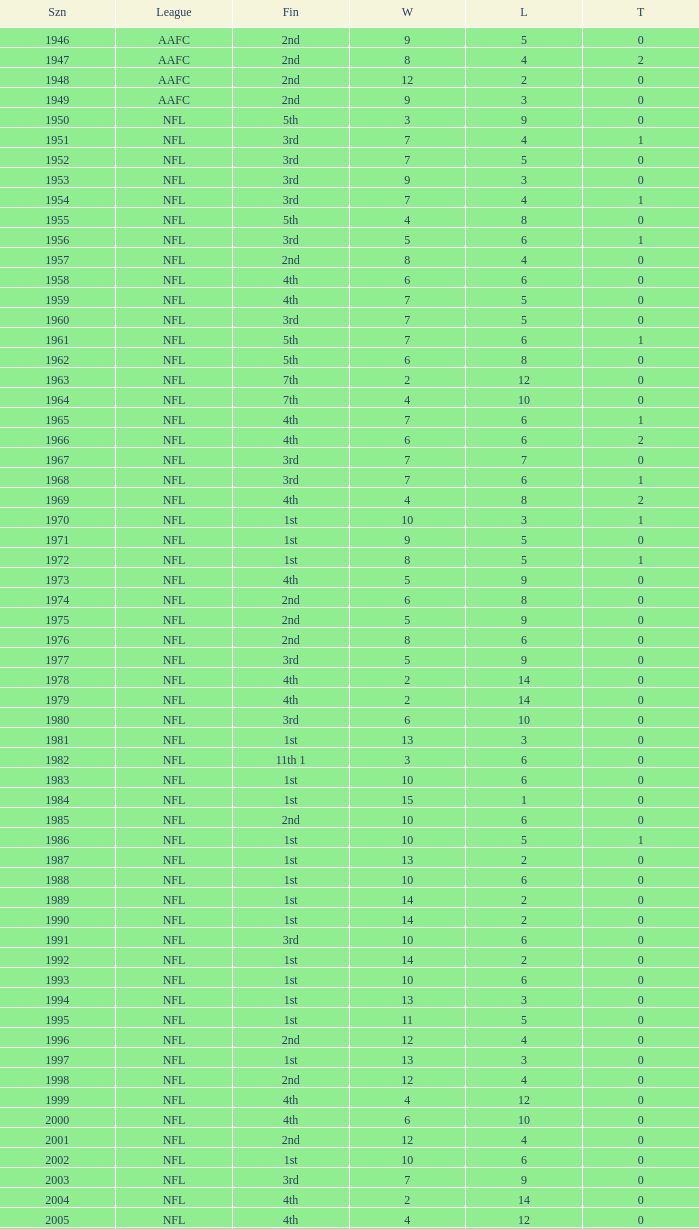What is the highest wins for the NFL with a finish of 1st, and more than 6 losses? None. 